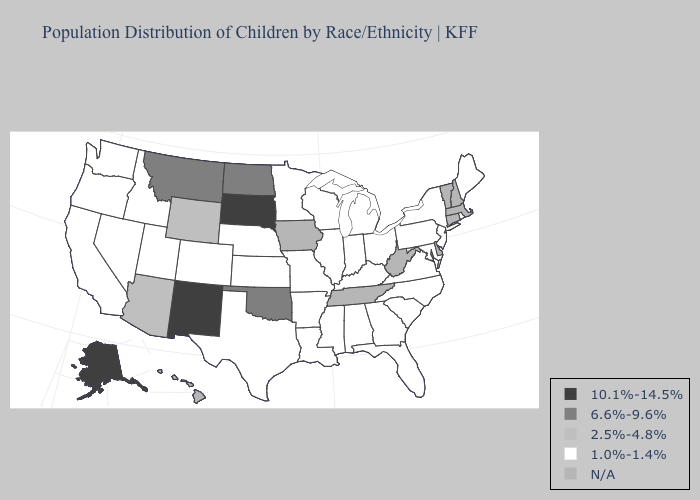What is the value of Massachusetts?
Be succinct. N/A. What is the lowest value in the USA?
Short answer required. 1.0%-1.4%. Does the map have missing data?
Quick response, please. Yes. What is the lowest value in states that border Montana?
Answer briefly. 1.0%-1.4%. Does Oklahoma have the lowest value in the South?
Concise answer only. No. Which states have the lowest value in the USA?
Short answer required. Alabama, Arkansas, California, Colorado, Florida, Georgia, Idaho, Illinois, Indiana, Kansas, Kentucky, Louisiana, Maine, Maryland, Michigan, Minnesota, Mississippi, Missouri, Nebraska, Nevada, New Jersey, New York, North Carolina, Ohio, Oregon, Pennsylvania, Rhode Island, South Carolina, Texas, Utah, Virginia, Washington, Wisconsin. Does Oregon have the lowest value in the West?
Keep it brief. Yes. Name the states that have a value in the range N/A?
Short answer required. Connecticut, Delaware, Hawaii, Iowa, Massachusetts, New Hampshire, Tennessee, Vermont, West Virginia. What is the value of Maryland?
Concise answer only. 1.0%-1.4%. Among the states that border Georgia , which have the lowest value?
Answer briefly. Alabama, Florida, North Carolina, South Carolina. Is the legend a continuous bar?
Short answer required. No. Which states have the lowest value in the USA?
Short answer required. Alabama, Arkansas, California, Colorado, Florida, Georgia, Idaho, Illinois, Indiana, Kansas, Kentucky, Louisiana, Maine, Maryland, Michigan, Minnesota, Mississippi, Missouri, Nebraska, Nevada, New Jersey, New York, North Carolina, Ohio, Oregon, Pennsylvania, Rhode Island, South Carolina, Texas, Utah, Virginia, Washington, Wisconsin. Name the states that have a value in the range 2.5%-4.8%?
Keep it brief. Arizona, Wyoming. 